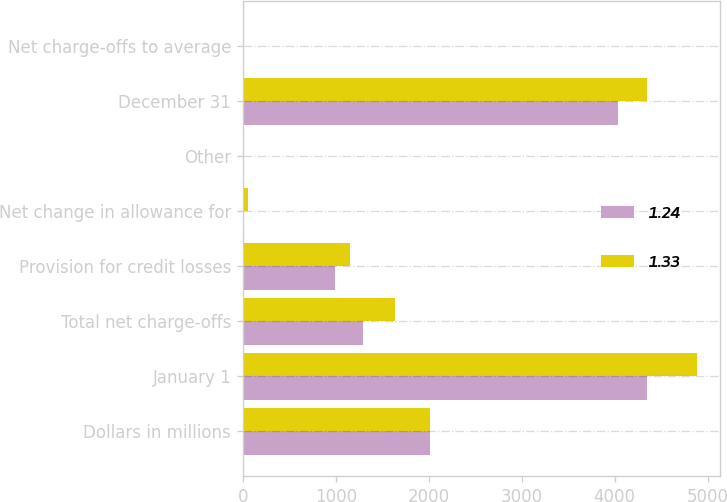Convert chart. <chart><loc_0><loc_0><loc_500><loc_500><stacked_bar_chart><ecel><fcel>Dollars in millions<fcel>January 1<fcel>Total net charge-offs<fcel>Provision for credit losses<fcel>Net change in allowance for<fcel>Other<fcel>December 31<fcel>Net charge-offs to average<nl><fcel>1.24<fcel>2012<fcel>4347<fcel>1289<fcel>987<fcel>10<fcel>1<fcel>4036<fcel>0.73<nl><fcel>1.33<fcel>2011<fcel>4887<fcel>1639<fcel>1152<fcel>52<fcel>1<fcel>4347<fcel>1.08<nl></chart> 